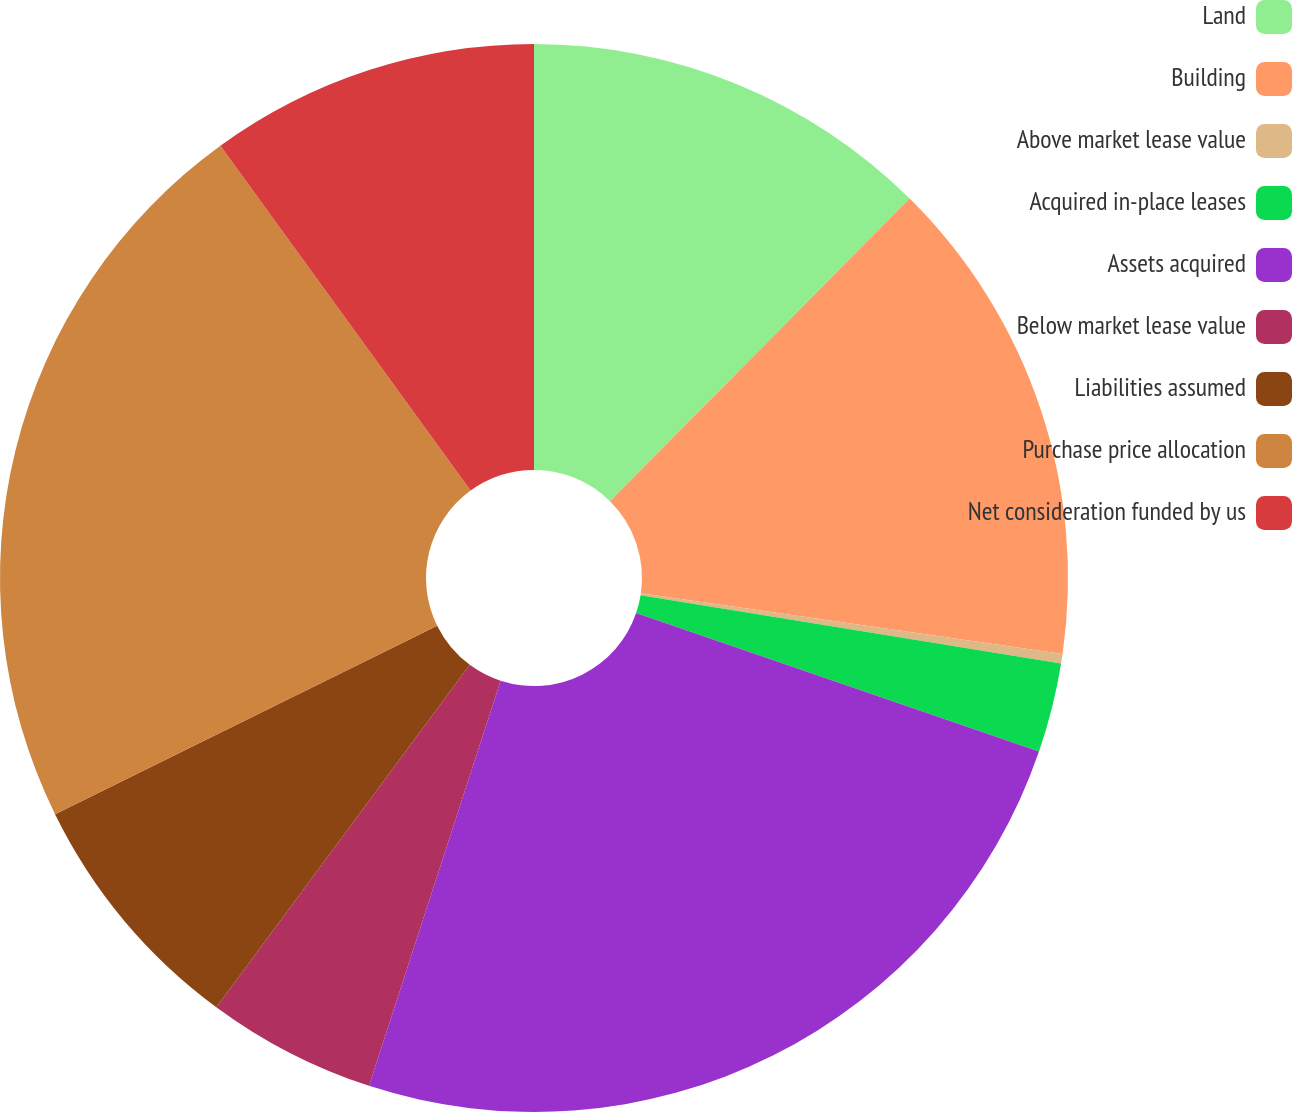Convert chart. <chart><loc_0><loc_0><loc_500><loc_500><pie_chart><fcel>Land<fcel>Building<fcel>Above market lease value<fcel>Acquired in-place leases<fcel>Assets acquired<fcel>Below market lease value<fcel>Liabilities assumed<fcel>Purchase price allocation<fcel>Net consideration funded by us<nl><fcel>12.42%<fcel>14.85%<fcel>0.29%<fcel>2.71%<fcel>24.73%<fcel>5.14%<fcel>7.57%<fcel>22.3%<fcel>9.99%<nl></chart> 